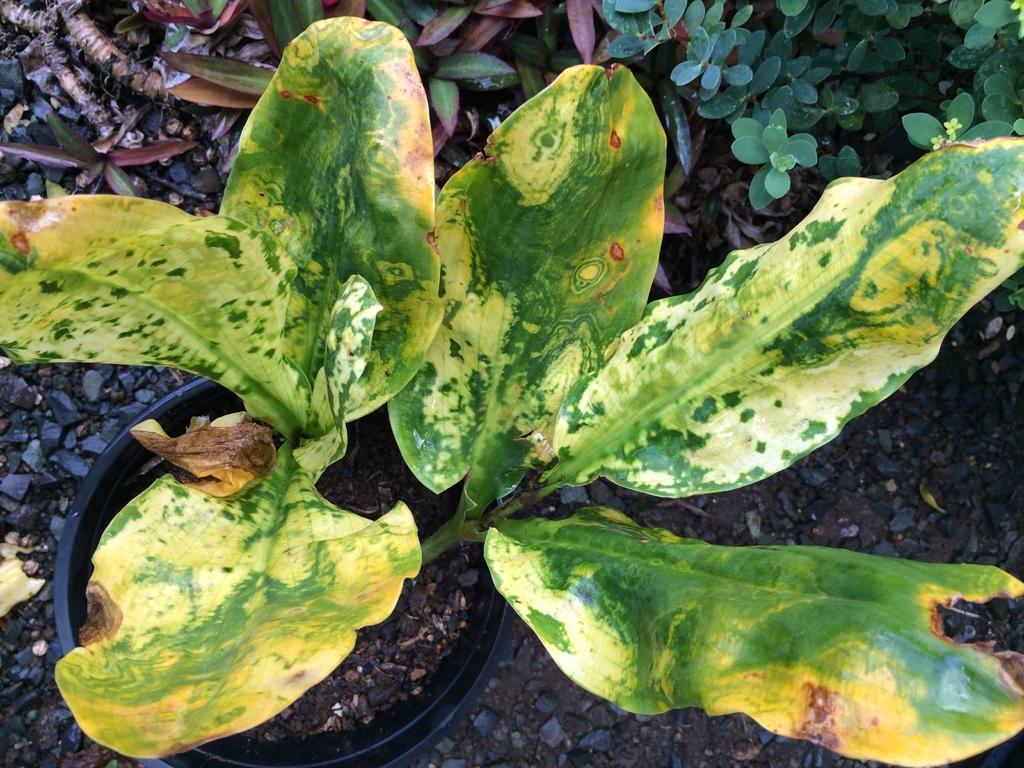Describe this image in one or two sentences. In this image there are plants. 